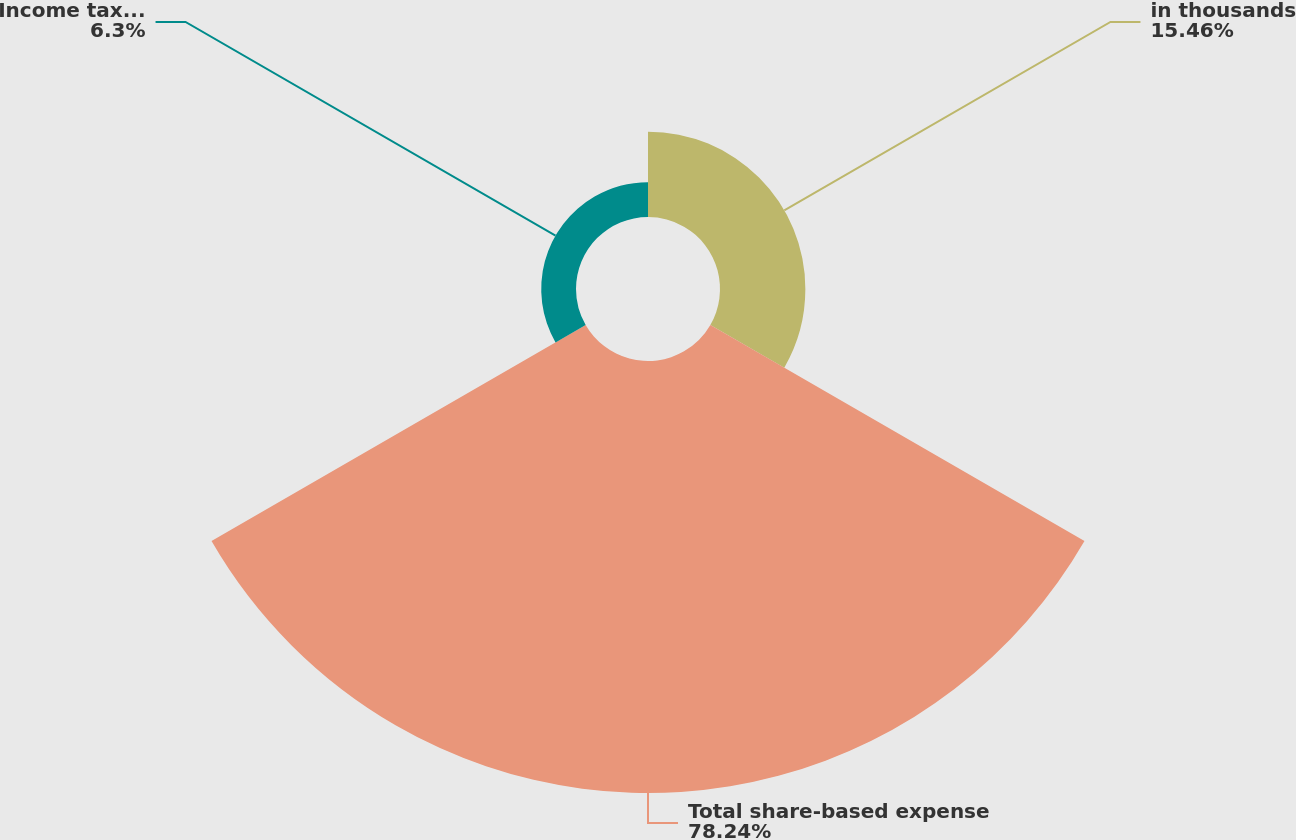Convert chart. <chart><loc_0><loc_0><loc_500><loc_500><pie_chart><fcel>in thousands<fcel>Total share-based expense<fcel>Income tax benefit related to<nl><fcel>15.46%<fcel>78.24%<fcel>6.3%<nl></chart> 